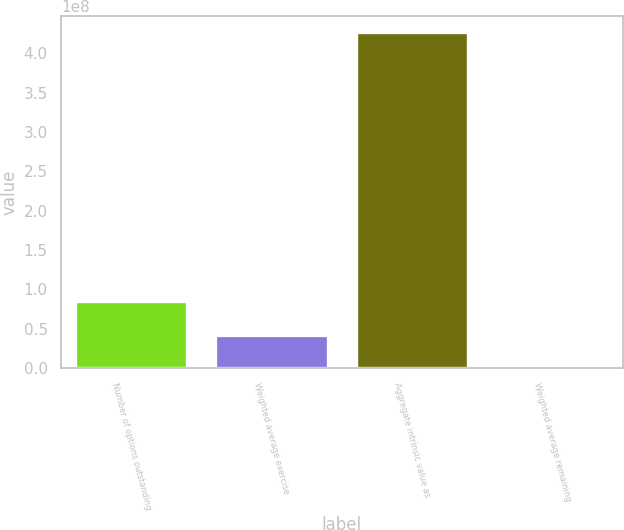<chart> <loc_0><loc_0><loc_500><loc_500><bar_chart><fcel>Number of options outstanding<fcel>Weighted average exercise<fcel>Aggregate intrinsic value as<fcel>Weighted average remaining<nl><fcel>8.52497e+07<fcel>4.26249e+07<fcel>4.26249e+08<fcel>2.9<nl></chart> 